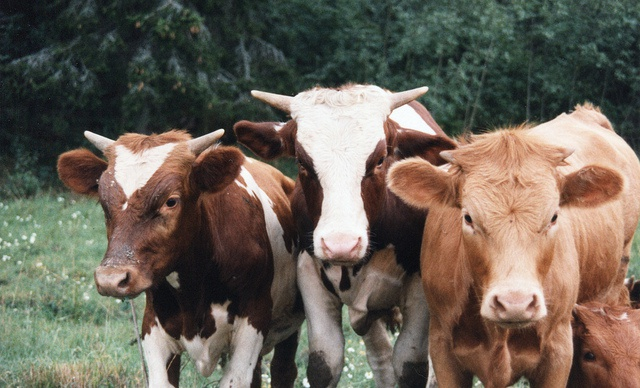Describe the objects in this image and their specific colors. I can see cow in black, tan, brown, and lightgray tones, cow in black, maroon, gray, and lightgray tones, cow in black, white, gray, and maroon tones, and cow in black, brown, maroon, and salmon tones in this image. 